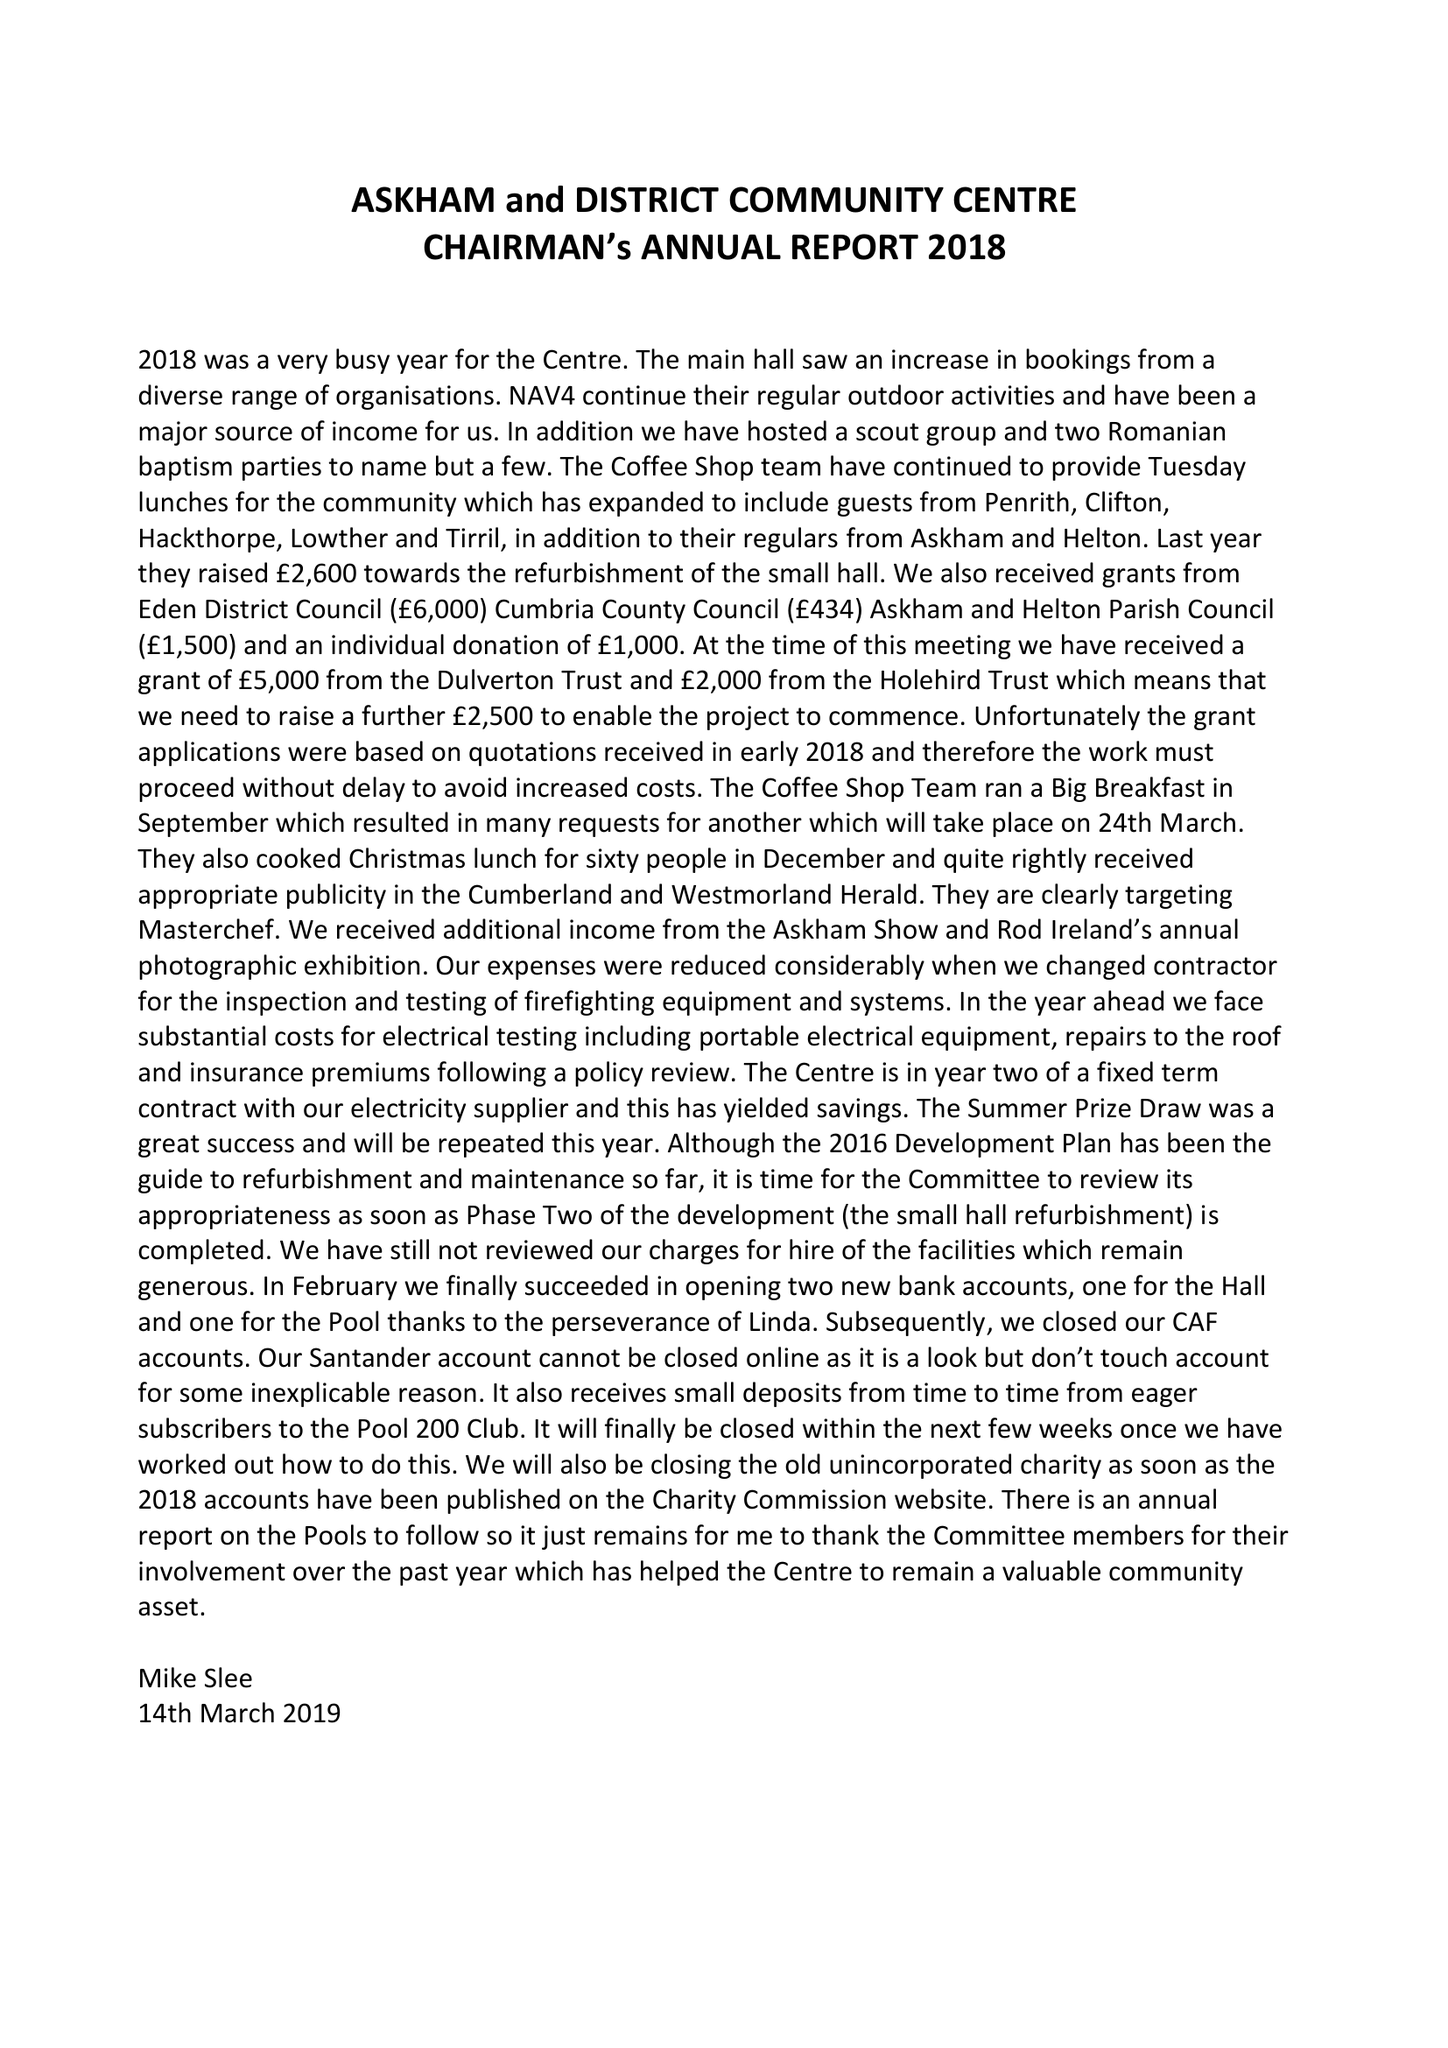What is the value for the address__post_town?
Answer the question using a single word or phrase. PENRITH 